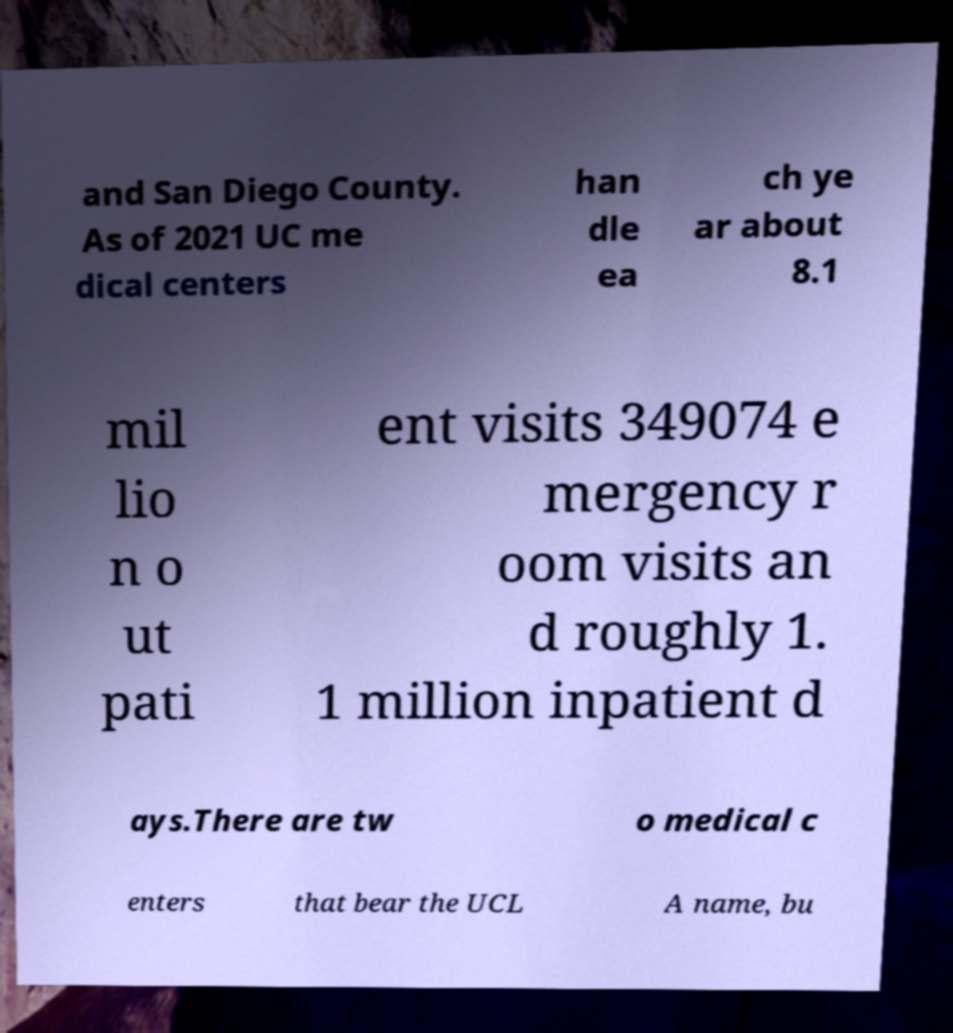What messages or text are displayed in this image? I need them in a readable, typed format. and San Diego County. As of 2021 UC me dical centers han dle ea ch ye ar about 8.1 mil lio n o ut pati ent visits 349074 e mergency r oom visits an d roughly 1. 1 million inpatient d ays.There are tw o medical c enters that bear the UCL A name, bu 